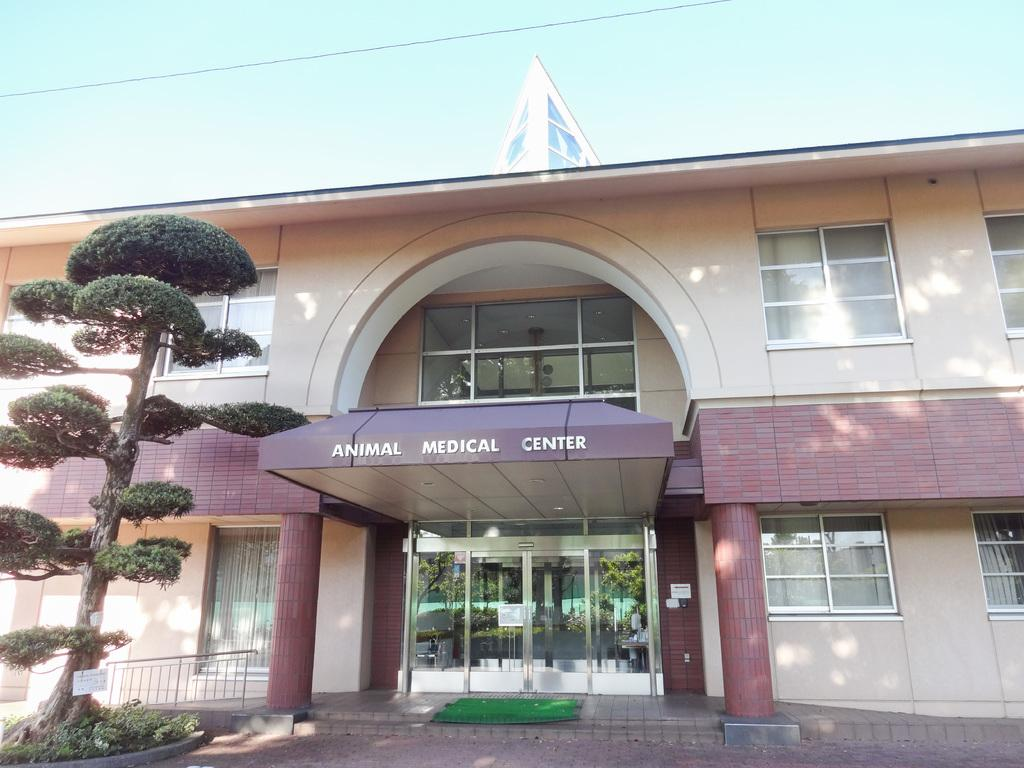<image>
Present a compact description of the photo's key features. Animal Medical Center is in white letters on the awning of the building. 